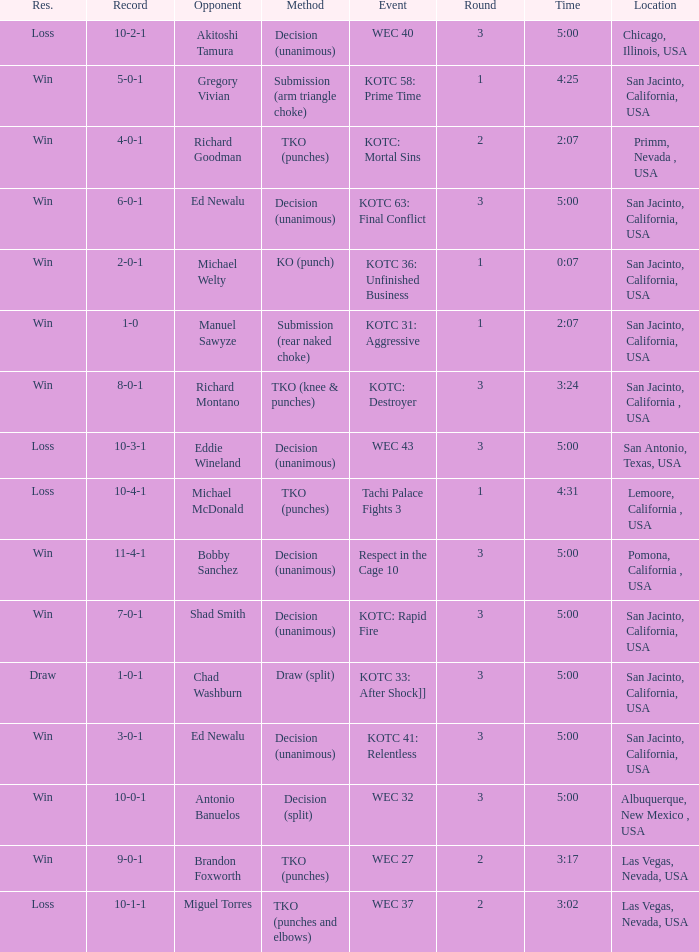What location did the event kotc: mortal sins take place? Primm, Nevada , USA. 